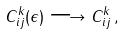<formula> <loc_0><loc_0><loc_500><loc_500>C _ { i j } ^ { k } ( \epsilon ) \longrightarrow C _ { i j } ^ { k } \, ,</formula> 